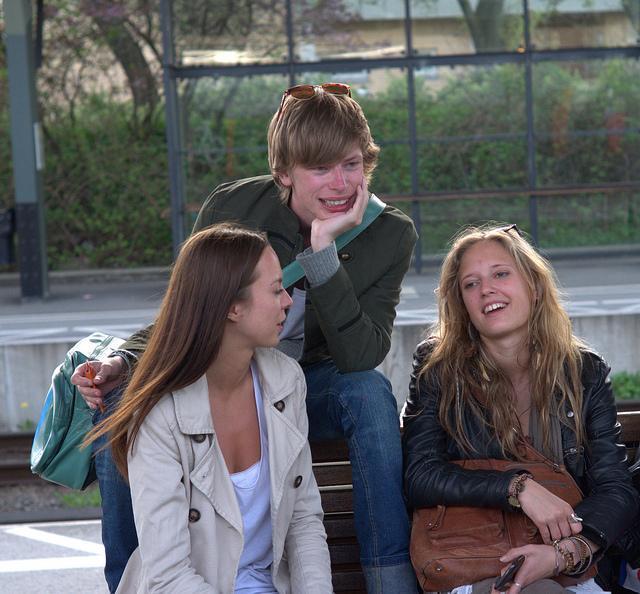How many bags are there?
Give a very brief answer. 2. How many handbags can you see?
Give a very brief answer. 2. How many people are in the picture?
Give a very brief answer. 3. 